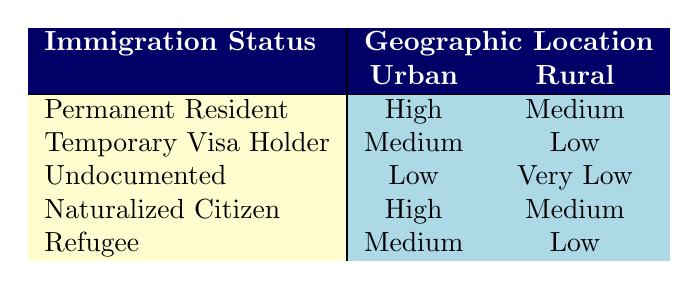What is the access to healthcare for Permanent Residents in Urban areas? The table shows that for Permanent Residents located in Urban areas, the access to healthcare is categorized as "High."
Answer: High How does the access to healthcare for Undocumented immigrants in Rural areas compare to that of Temporary Visa Holders in Rural areas? For Undocumented immigrants in Rural areas, the access is "Very Low," while for Temporary Visa Holders in Rural areas, it is "Low." Since "Very Low" is worse than "Low," Undocumented immigrants have less access than Temporary Visa Holders in Rural areas.
Answer: Undocumented immigrants have less access Is the access to healthcare for Naturalized Citizens in Urban areas higher than that for Refugees in Rural areas? For Naturalized Citizens in Urban areas, access to healthcare is "High." For Refugees in Rural areas, it is "Low." Since "High" is better than "Low," Naturalized Citizens have higher access.
Answer: Yes What is the average access level of healthcare for all immigration statuses in Urban areas? The access levels for Urban areas are: High (Permanent Resident), Medium (Temporary Visa Holder), Low (Undocumented), High (Naturalized Citizen), Medium (Refugee). Converting these to numerical values: High = 3, Medium = 2, Low = 1. The average is (3 + 2 + 1 + 3 + 2) / 5 = 2.2.
Answer: 2.2 Are there any immigration statuses that have 'Very Low' access to healthcare in Urban areas? The table shows that 'Very Low' access is recorded only for Undocumented immigrants in Rural areas, and no immigration statuses have 'Very Low' access in Urban areas.
Answer: No 